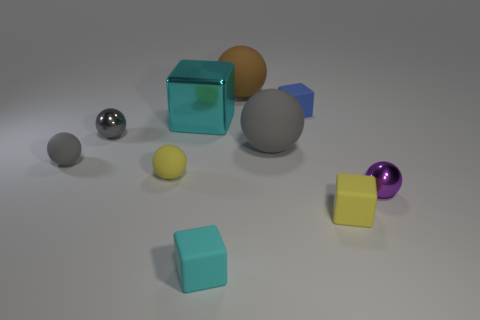How many gray balls must be subtracted to get 1 gray balls? 2 Subtract all purple blocks. How many gray balls are left? 3 Subtract all yellow spheres. How many spheres are left? 5 Subtract all purple metal spheres. How many spheres are left? 5 Subtract 2 cubes. How many cubes are left? 2 Subtract all yellow spheres. Subtract all cyan cylinders. How many spheres are left? 5 Subtract all cubes. How many objects are left? 6 Subtract all cyan things. Subtract all tiny gray spheres. How many objects are left? 6 Add 8 gray matte objects. How many gray matte objects are left? 10 Add 4 tiny yellow matte blocks. How many tiny yellow matte blocks exist? 5 